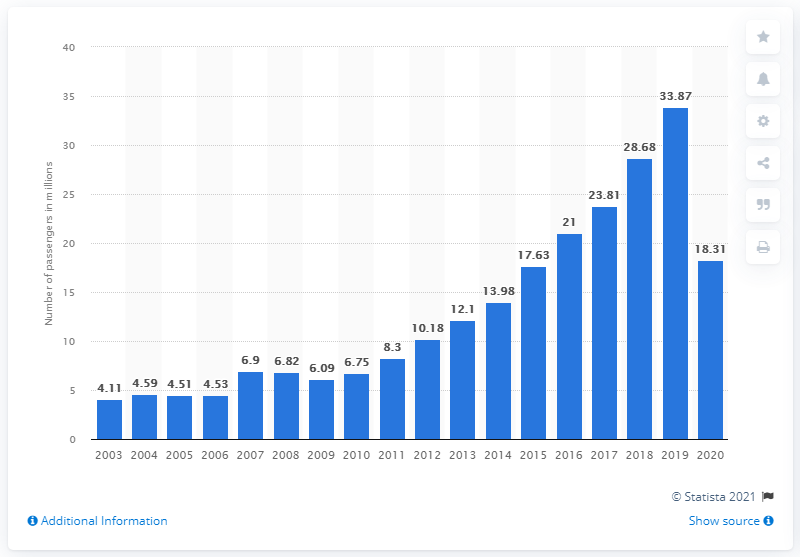Mention a couple of crucial points in this snapshot. Spirit Airlines carried a total of 33,870 passengers in the previous year. Spirit Airlines carried a total of 18,310 passengers in 2020. 